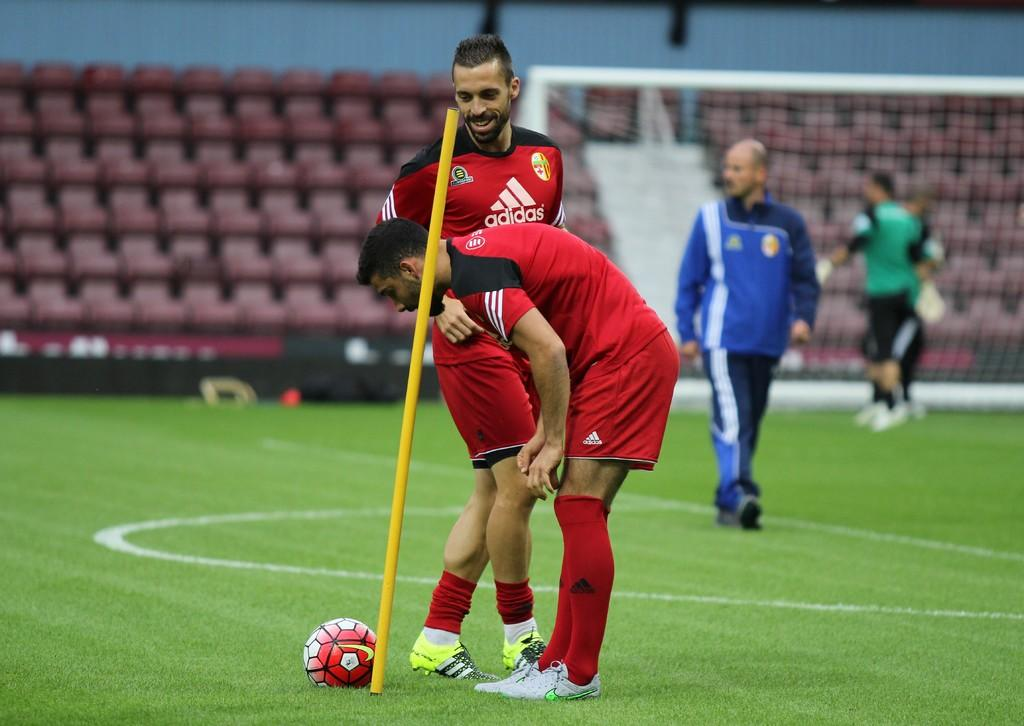<image>
Describe the image concisely. Two soccer players are wearing uniforms sponsored by Adidas. 